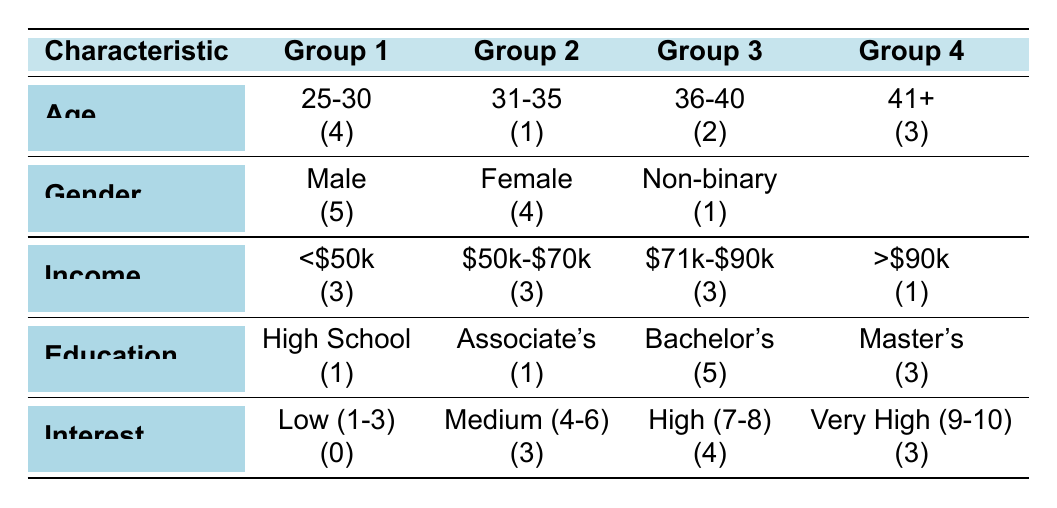What is the total number of respondents aged 25-30? According to the table, under the age characteristic, the group labeled 25-30 has 4 respondents.
Answer: 4 How many respondents identified as Non-binary? The gender section of the table indicates that there is 1 respondent who identified as Non-binary.
Answer: 1 Is there any respondent with a high level of interest (9-10) who is also in the age group of 41+? A search through the interest and age groups shows that there are no respondents aged 41 or older with an interest level of 9 or 10; in fact, all those aged 41+ have lower interest scores.
Answer: No What percentage of respondents have an income of $70k or more? Three respondents fall into the income group of $71k-$90k and one respondent is in the >$90k group. The total respondents are 10. So, the percentage calculation is ((3 + 1)/10)*100 = 40%.
Answer: 40% How many Female respondents have a Master's degree? There are 4 Female respondents, and among the educational qualifications, 3 respondents have a Master's degree; we need to check from the individuals listed that two of them are Female.
Answer: 2 Is it true that all respondents with a Bachelor's degree have an interest level higher than 6? Looking at the Bachelor's degree group, there are 5 respondents, and their interest levels are 8, 7, 6, 9, and 8. One has a score of 6. Therefore, the statement is false.
Answer: No How many respondents in total have either a Master's degree or earn more than $90k? In the Master's group, there are 3 respondents, and in the income group above $90k, there is 1 respondent. The Master's degree holders, however, may overlap with high earners. To get a count without overlap, we notice that no Master's degree holders also belong to the >$90k category. Thus, the total is 3 + 1 = 4.
Answer: 4 What is the highest level of education among respondents who earn less than $50k? The income group of less than $50k has 3 respondents, and of those, only 1 has a High School diploma; therefore, the highest level is High School.
Answer: High School How does the number of respondents interested in the product at a very high level (9-10) compare to those with a medium level (4-6)? Looking at the table, 3 respondents fall in the very high interest category, and 3 are categorized within medium interest. This indicates that they are equal.
Answer: Equal Who has the most respondents in their respective age group? In the age groups, the range 25-30 has the highest count with 4 respondents. The other groups have fewer: 31-35 has 1, 36-40 has 2, and 41+ has 3.
Answer: 25-30 